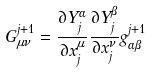<formula> <loc_0><loc_0><loc_500><loc_500>G ^ { j + 1 } _ { \mu \nu } = \frac { \partial Y _ { j } ^ { \alpha } } { \partial x _ { j } ^ { \mu } } \frac { \partial Y _ { j } ^ { \beta } } { \partial x _ { j } ^ { \nu } } g ^ { j + 1 } _ { \alpha \beta }</formula> 